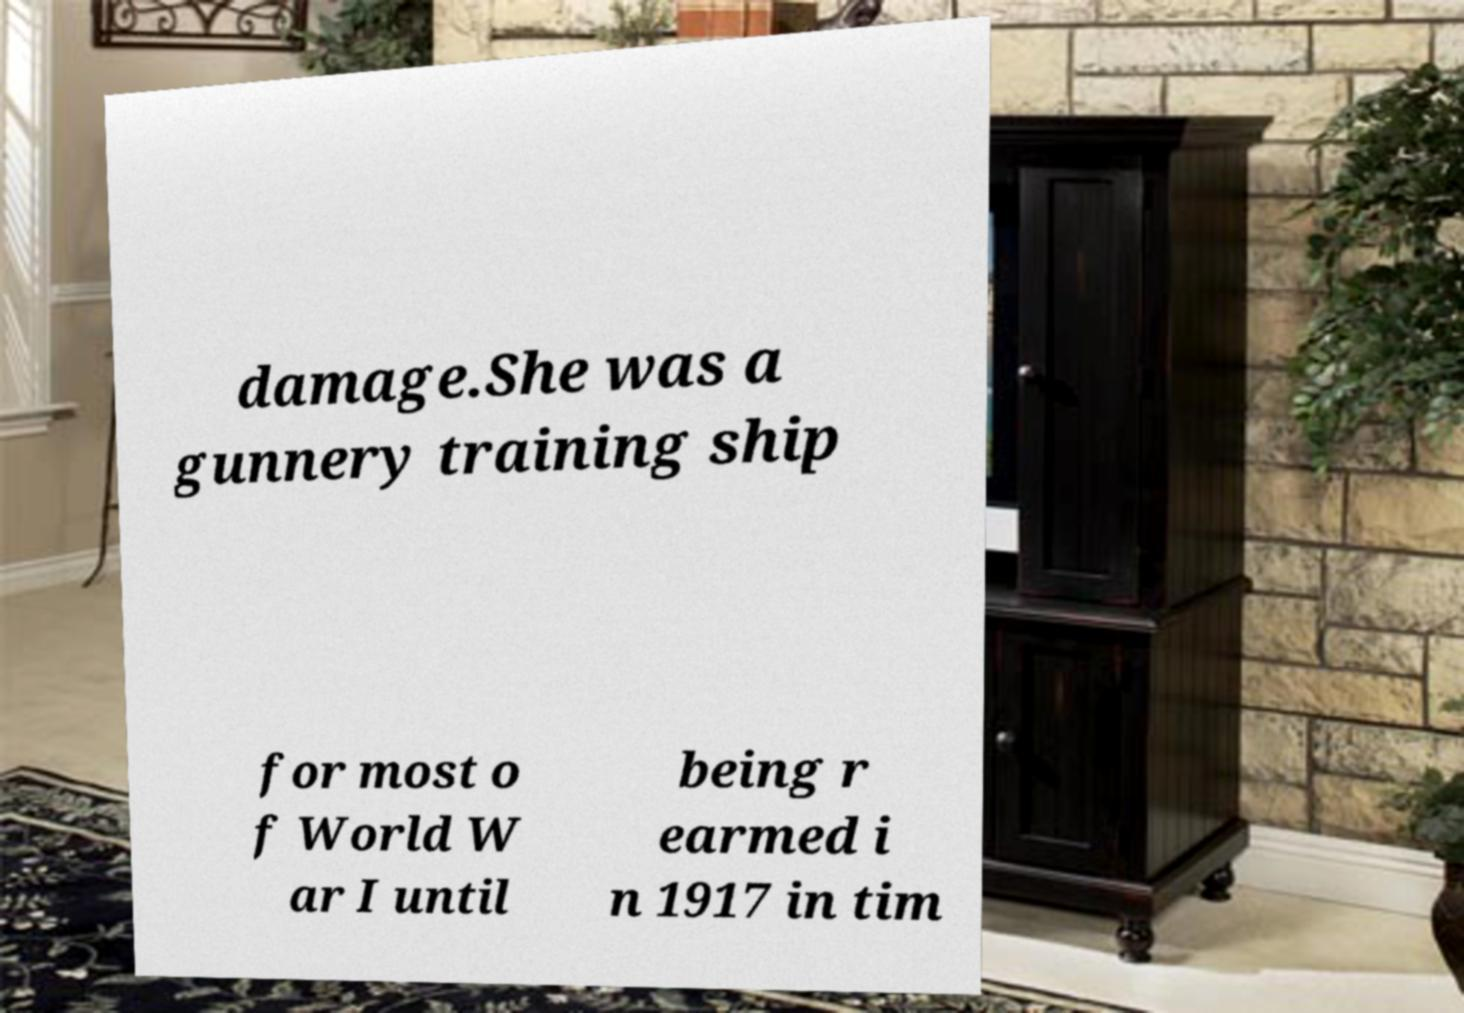Could you extract and type out the text from this image? damage.She was a gunnery training ship for most o f World W ar I until being r earmed i n 1917 in tim 